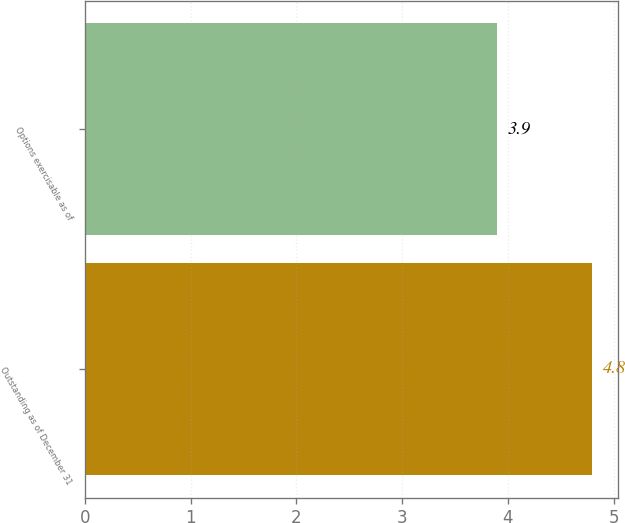Convert chart. <chart><loc_0><loc_0><loc_500><loc_500><bar_chart><fcel>Outstanding as of December 31<fcel>Options exercisable as of<nl><fcel>4.8<fcel>3.9<nl></chart> 